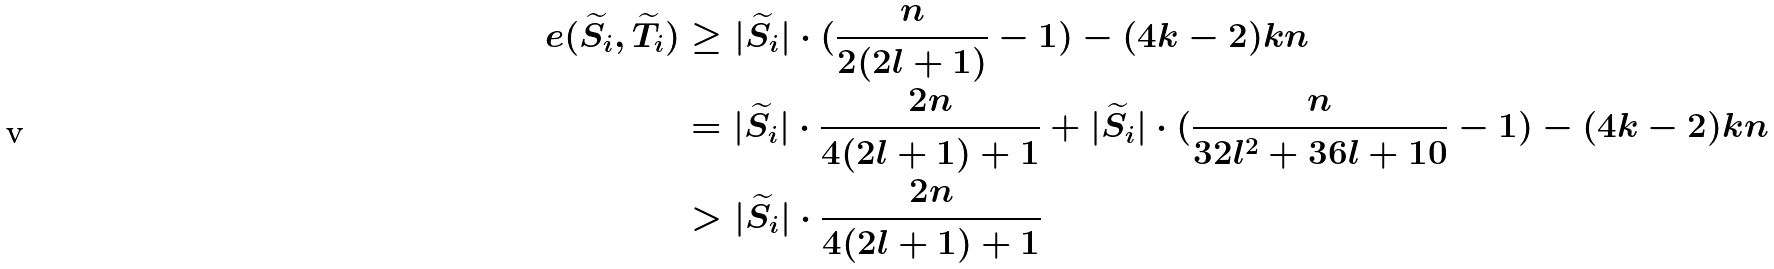Convert formula to latex. <formula><loc_0><loc_0><loc_500><loc_500>e ( \widetilde { S _ { i } } , \widetilde { T _ { i } } ) & \geq | \widetilde { S _ { i } } | \cdot ( \frac { n } { 2 ( 2 l + 1 ) } - 1 ) - ( 4 k - 2 ) k n \\ & = | \widetilde { S _ { i } } | \cdot \frac { 2 n } { 4 ( 2 l + 1 ) + 1 } + | \widetilde { S _ { i } } | \cdot ( \frac { n } { 3 2 l ^ { 2 } + 3 6 l + 1 0 } - 1 ) - ( 4 k - 2 ) k n \\ & > | \widetilde { S _ { i } } | \cdot \frac { 2 n } { 4 ( 2 l + 1 ) + 1 }</formula> 